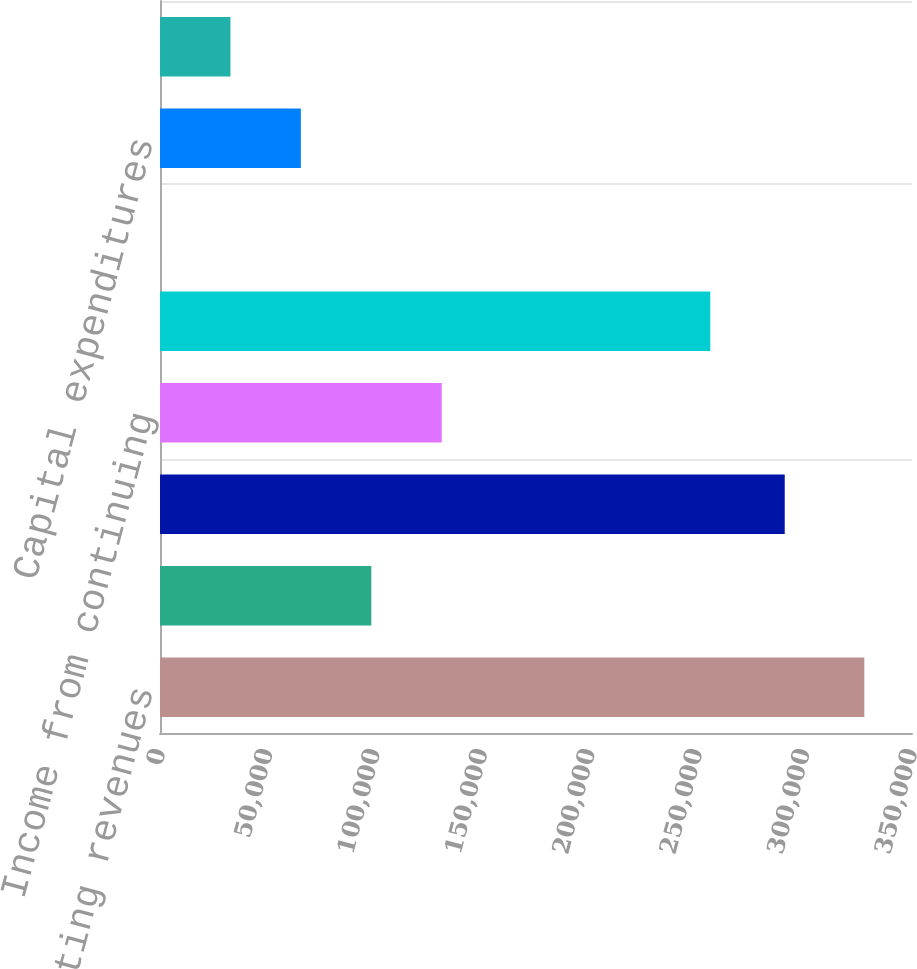<chart> <loc_0><loc_0><loc_500><loc_500><bar_chart><fcel>Net operating revenues<fcel>Depreciation and amortization<fcel>Total operating expenses net<fcel>Income from continuing<fcel>Total assets<fcel>Assets of discontinued<fcel>Capital expenditures<fcel>Capital expenditures of<nl><fcel>327815<fcel>98347.7<fcel>290768<fcel>131129<fcel>256110<fcel>4.55<fcel>65566.6<fcel>32785.6<nl></chart> 